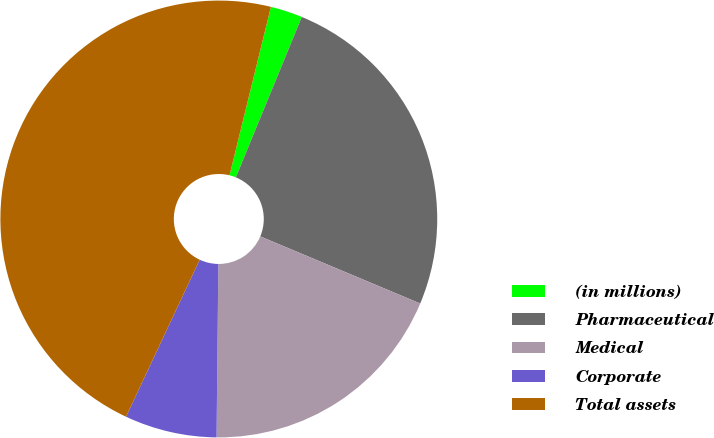<chart> <loc_0><loc_0><loc_500><loc_500><pie_chart><fcel>(in millions)<fcel>Pharmaceutical<fcel>Medical<fcel>Corporate<fcel>Total assets<nl><fcel>2.37%<fcel>25.12%<fcel>18.84%<fcel>6.82%<fcel>46.85%<nl></chart> 